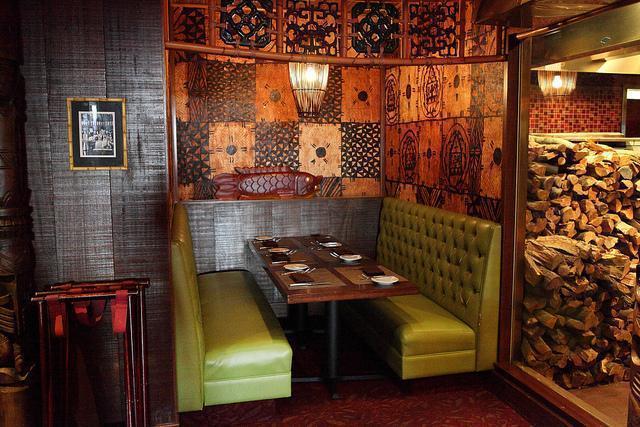How many people could fit comfortably in each booth?
Select the accurate answer and provide explanation: 'Answer: answer
Rationale: rationale.'
Options: Four, fifteen, eight, ten. Answer: four.
Rationale: This would give people room to move their arms as they eat 